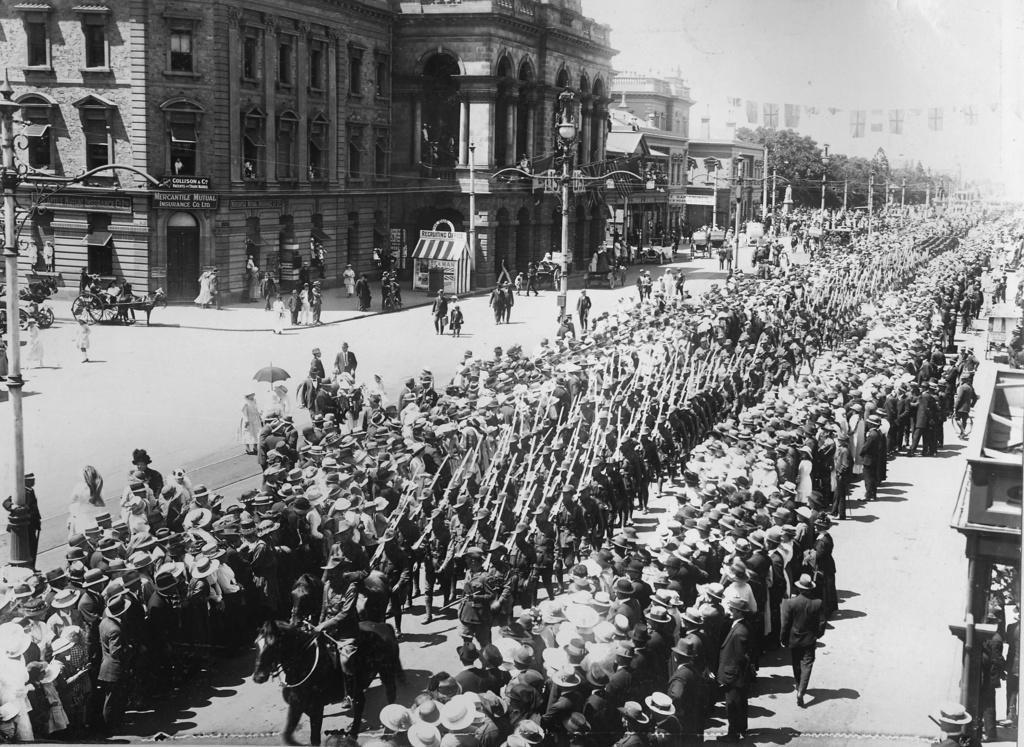In one or two sentences, can you explain what this image depicts? This is a black and white image. In the image we can see buildings, street poles, street lights, horse carts and persons walking on the road. 